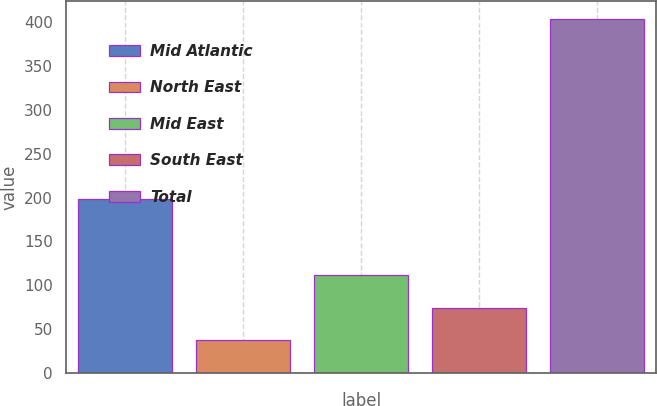Convert chart to OTSL. <chart><loc_0><loc_0><loc_500><loc_500><bar_chart><fcel>Mid Atlantic<fcel>North East<fcel>Mid East<fcel>South East<fcel>Total<nl><fcel>198<fcel>38<fcel>111.2<fcel>74.6<fcel>404<nl></chart> 